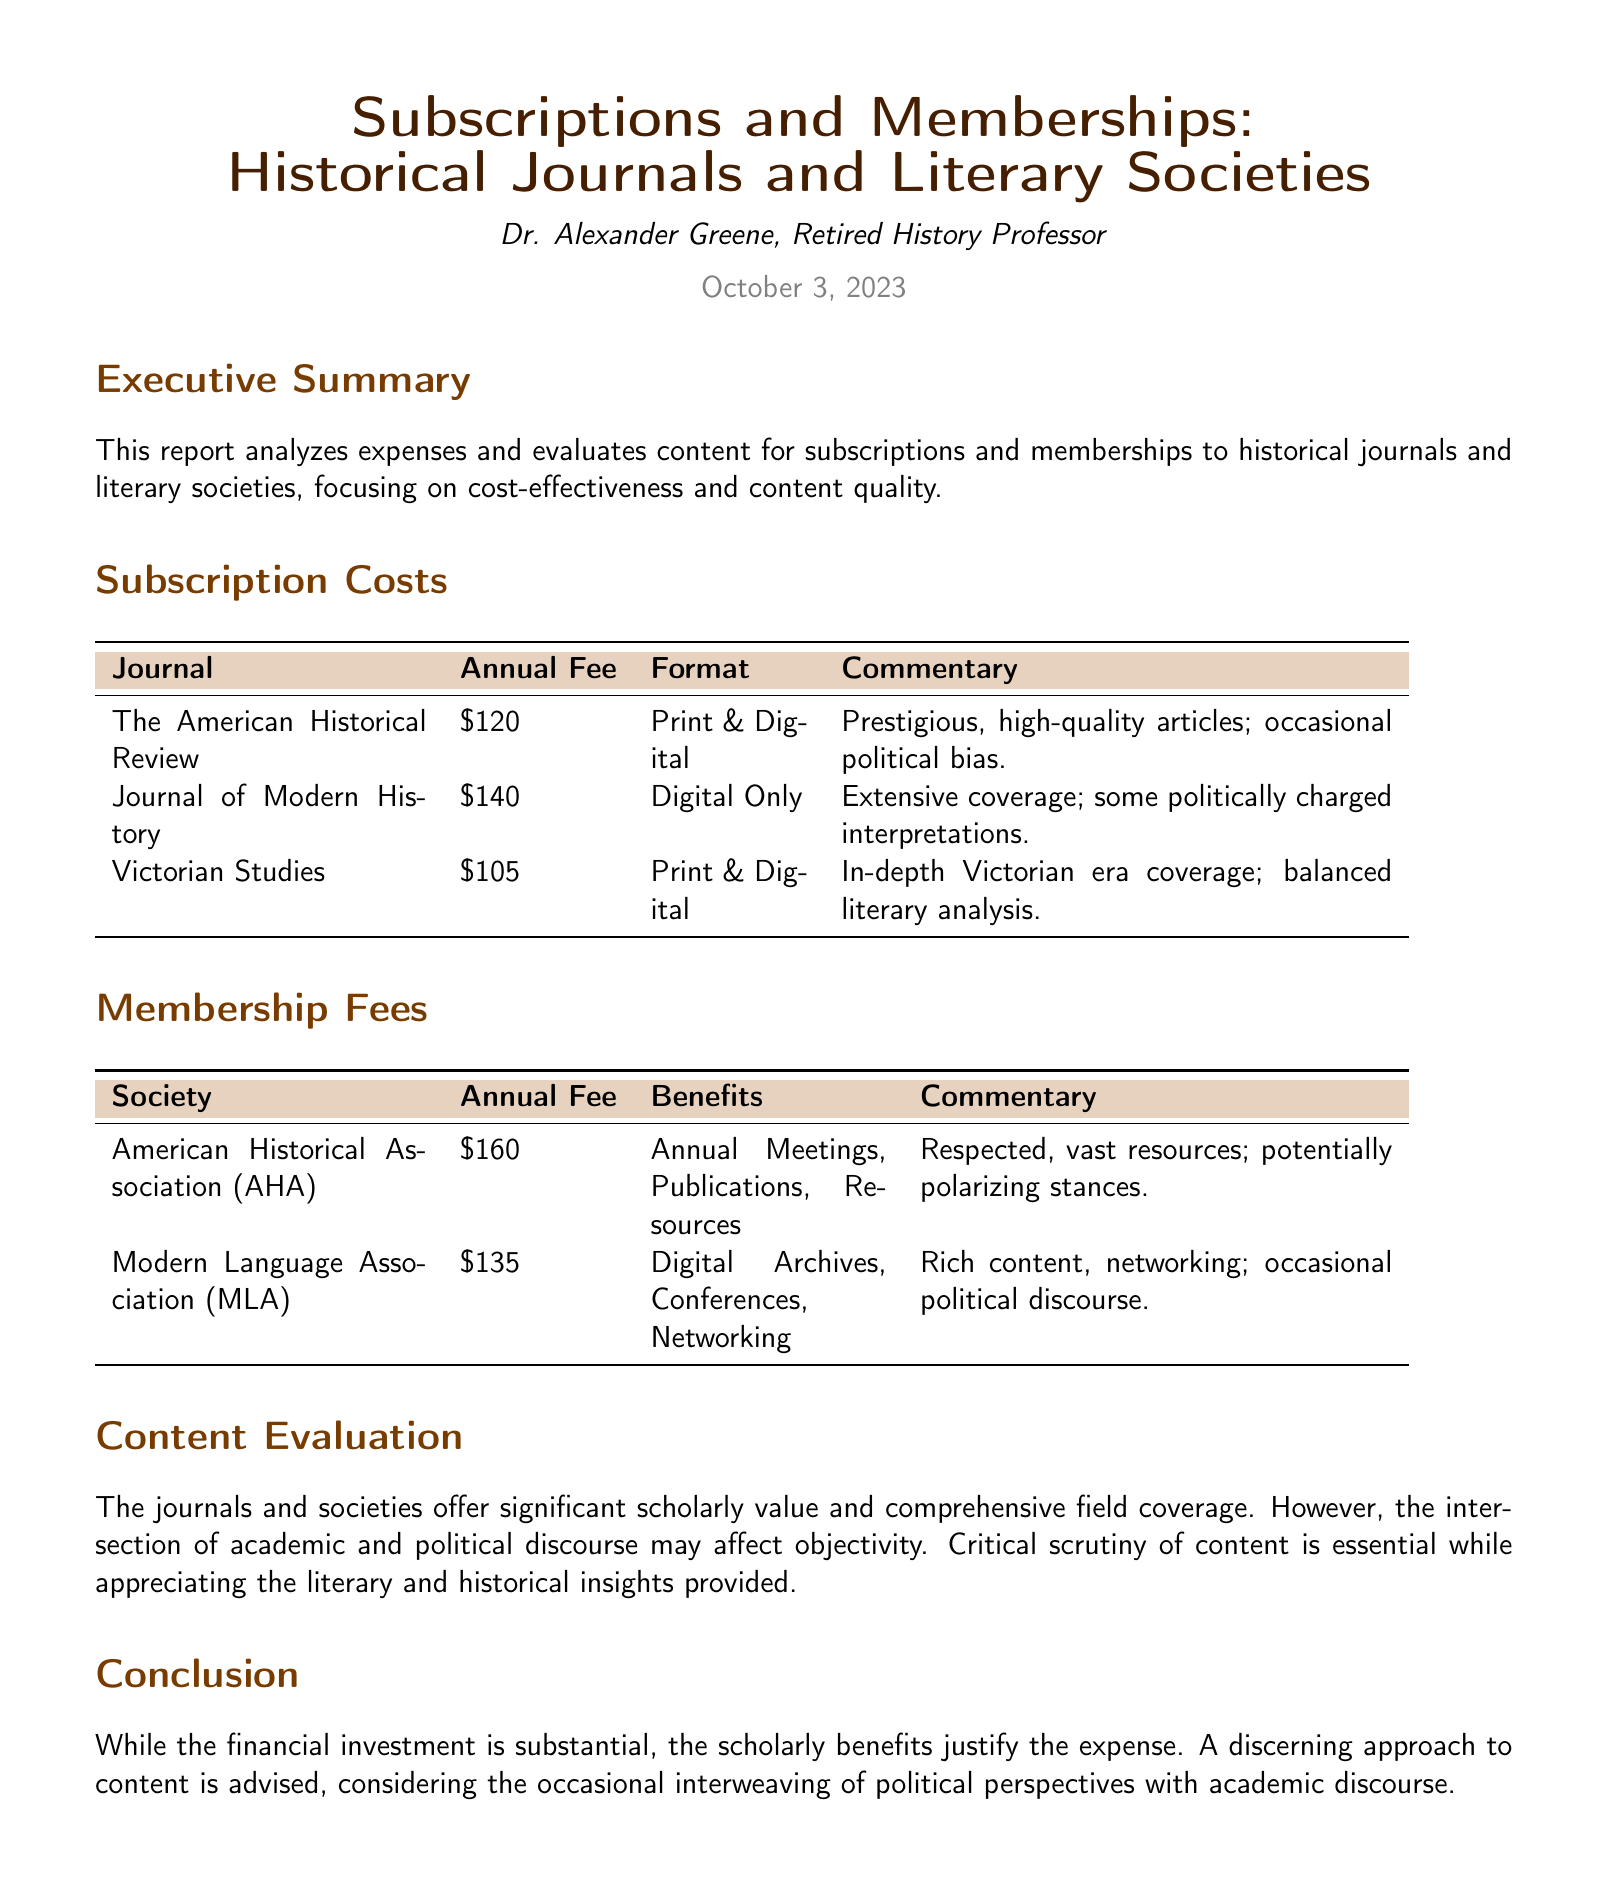What is the total annual fee for The American Historical Review? The total annual fee is a specific figure listed in the document for that journal, which is $120.
Answer: $120 What format is Victorian Studies available in? The format is mentioned in the document, and Victorian Studies is available in both print and digital.
Answer: Print & Digital How much is the membership fee for the American Historical Association? The membership fee is explicitly stated in the document, which is $160.
Answer: $160 Which society offers digital archives as a benefit? The Modern Language Association is the society mentioned in the document that provides digital archives as a membership benefit.
Answer: Modern Language Association What are the two main types of content evaluated in this report? The content evaluation addresses both scholarly value and the influence of political discourse within the journals and societies.
Answer: Scholarly value and political discourse Which journal has extensive coverage but occasionally politically charged interpretations? The journal that fits this description, as per the document, is the Journal of Modern History.
Answer: Journal of Modern History What is the main concern regarding the intersection of academic and political discourse? The document discusses the potential effect on objectivity due to this intersection, indicating that it may compromise impartiality.
Answer: Objectivity How does the report characterize the commentary on the American Historical Association? The commentary describes the association as respected and mentions that they have potentially polarizing stances.
Answer: Respected; potentially polarizing stances What is the focus of the executive summary in this report? The focus of the executive summary revolves around the analysis of expenses and the evaluation of content for historical journals and literary societies.
Answer: Expense analysis and content evaluation 